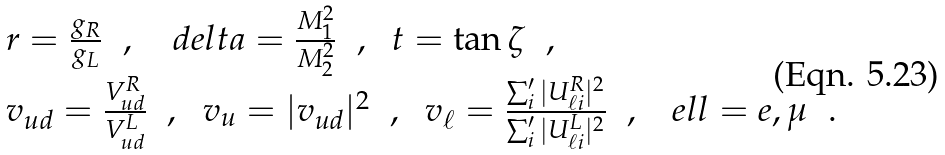<formula> <loc_0><loc_0><loc_500><loc_500>\begin{array} { r l } & r = \frac { g _ { R } } { g _ { L } } \ \ , \quad d e l t a = \frac { M ^ { 2 } _ { 1 } } { M ^ { 2 } _ { 2 } } \ \ , \ \ t = \tan \zeta \ \ , \\ & v _ { u d } = \frac { V ^ { R } _ { u d } } { V ^ { L } _ { u d } } \ \ , \ \ v _ { u } = | v _ { u d } | ^ { 2 } \ \ , \ \ v _ { \ell } = \frac { \sum _ { i } ^ { \prime } | U ^ { R } _ { \ell i } | ^ { 2 } } { \sum _ { i } ^ { \prime } | U ^ { L } _ { \ell i } | ^ { 2 } } \ \ , \ \ \ e l l = e , \mu \ \ . \end{array}</formula> 